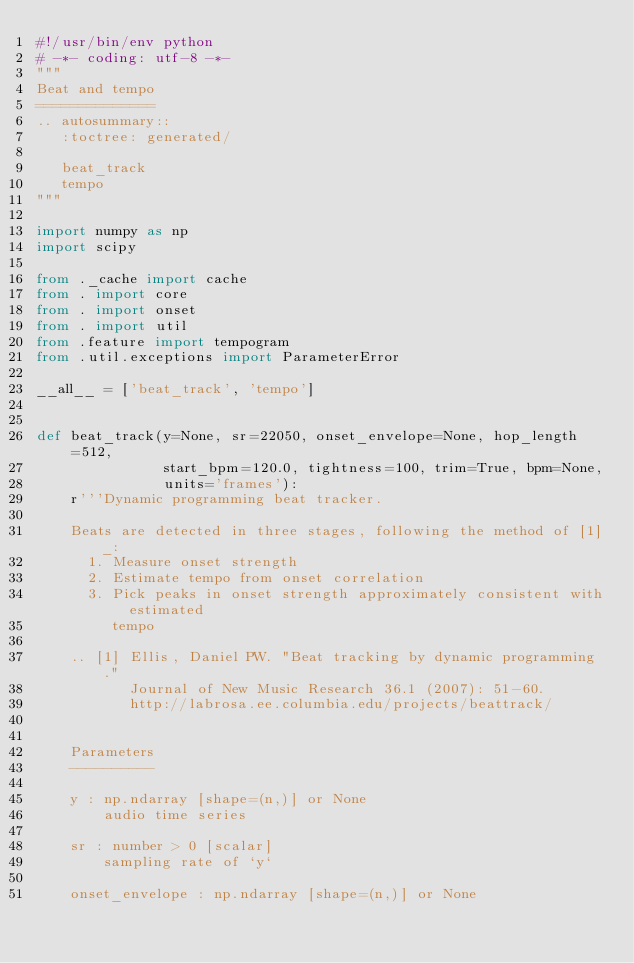<code> <loc_0><loc_0><loc_500><loc_500><_Python_>#!/usr/bin/env python
# -*- coding: utf-8 -*-
"""
Beat and tempo
==============
.. autosummary::
   :toctree: generated/

   beat_track
   tempo
"""

import numpy as np
import scipy

from ._cache import cache
from . import core
from . import onset
from . import util
from .feature import tempogram
from .util.exceptions import ParameterError

__all__ = ['beat_track', 'tempo']


def beat_track(y=None, sr=22050, onset_envelope=None, hop_length=512,
               start_bpm=120.0, tightness=100, trim=True, bpm=None,
               units='frames'):
    r'''Dynamic programming beat tracker.

    Beats are detected in three stages, following the method of [1]_:
      1. Measure onset strength
      2. Estimate tempo from onset correlation
      3. Pick peaks in onset strength approximately consistent with estimated
         tempo

    .. [1] Ellis, Daniel PW. "Beat tracking by dynamic programming."
           Journal of New Music Research 36.1 (2007): 51-60.
           http://labrosa.ee.columbia.edu/projects/beattrack/


    Parameters
    ----------

    y : np.ndarray [shape=(n,)] or None
        audio time series

    sr : number > 0 [scalar]
        sampling rate of `y`

    onset_envelope : np.ndarray [shape=(n,)] or None</code> 